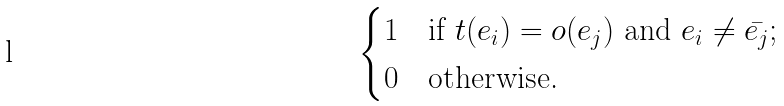Convert formula to latex. <formula><loc_0><loc_0><loc_500><loc_500>\begin{cases} 1 & \text {if $t(e_{i}) = o(e_{j})$ and $e_{i} \neq \bar{e_{j}}$;} \\ 0 & \text {otherwise.} \end{cases}</formula> 